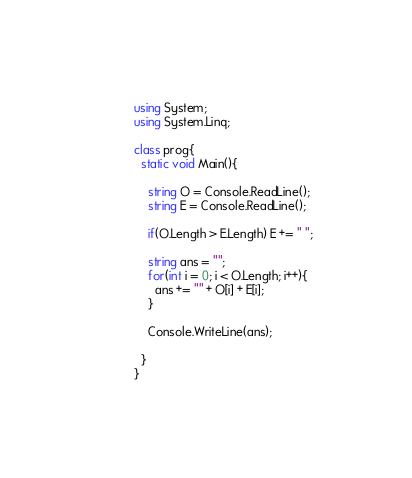Convert code to text. <code><loc_0><loc_0><loc_500><loc_500><_C#_>using System;
using System.Linq;

class prog{
  static void Main(){
    
    string O = Console.ReadLine();
    string E = Console.ReadLine();
    
    if(O.Length > E.Length) E += " ";
    
    string ans = "";
    for(int i = 0; i < O.Length; i++){
      ans += "" + O[i] + E[i];
    }
    
    Console.WriteLine(ans);
    
  }
}</code> 